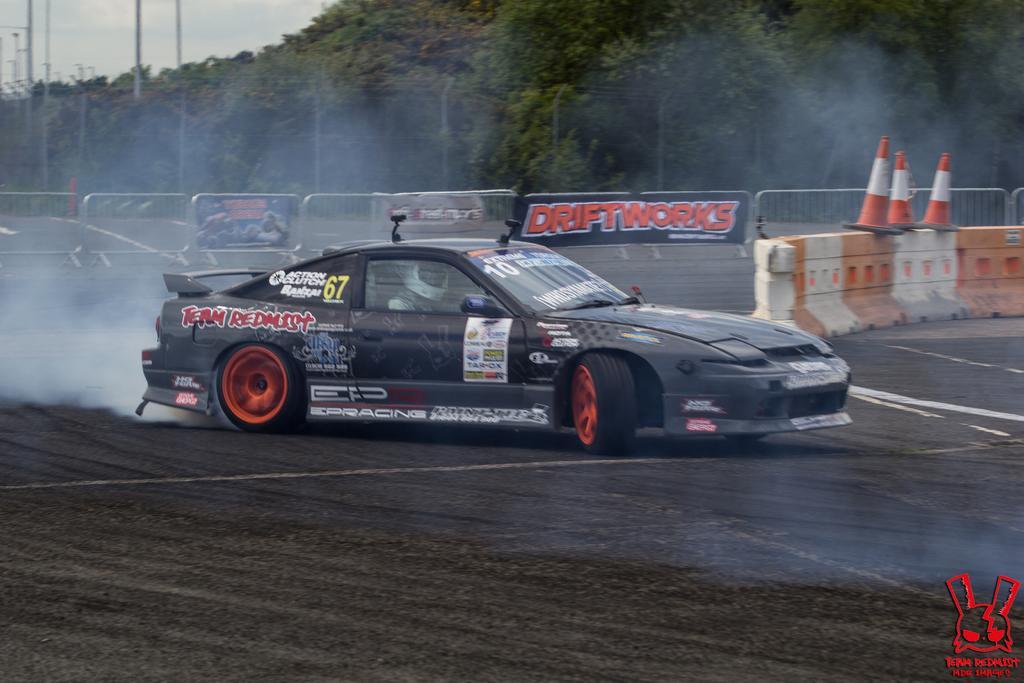Could you give a brief overview of what you see in this image? In this picture I can see a vehicle on the road, side there are some banners, fencing and background I can see some trees. 